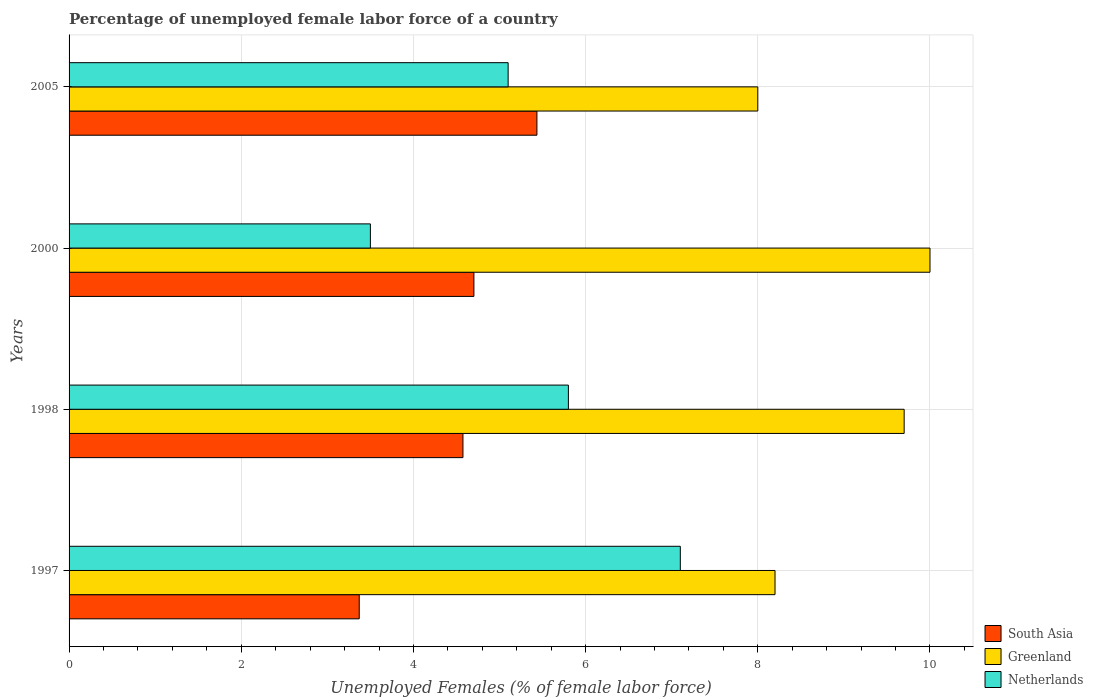How many groups of bars are there?
Provide a succinct answer. 4. Are the number of bars per tick equal to the number of legend labels?
Offer a very short reply. Yes. Are the number of bars on each tick of the Y-axis equal?
Offer a terse response. Yes. How many bars are there on the 3rd tick from the bottom?
Your answer should be compact. 3. What is the percentage of unemployed female labor force in South Asia in 1998?
Offer a very short reply. 4.58. Across all years, what is the maximum percentage of unemployed female labor force in South Asia?
Your answer should be compact. 5.43. Across all years, what is the minimum percentage of unemployed female labor force in South Asia?
Make the answer very short. 3.37. In which year was the percentage of unemployed female labor force in Greenland maximum?
Offer a terse response. 2000. What is the total percentage of unemployed female labor force in Greenland in the graph?
Provide a succinct answer. 35.9. What is the difference between the percentage of unemployed female labor force in Netherlands in 2000 and the percentage of unemployed female labor force in Greenland in 1998?
Provide a short and direct response. -6.2. What is the average percentage of unemployed female labor force in Greenland per year?
Offer a terse response. 8.97. In the year 1997, what is the difference between the percentage of unemployed female labor force in Greenland and percentage of unemployed female labor force in Netherlands?
Your answer should be very brief. 1.1. In how many years, is the percentage of unemployed female labor force in Greenland greater than 6.8 %?
Offer a very short reply. 4. What is the ratio of the percentage of unemployed female labor force in Netherlands in 1998 to that in 2005?
Your response must be concise. 1.14. Is the percentage of unemployed female labor force in Greenland in 1997 less than that in 2000?
Give a very brief answer. Yes. Is the difference between the percentage of unemployed female labor force in Greenland in 1998 and 2005 greater than the difference between the percentage of unemployed female labor force in Netherlands in 1998 and 2005?
Provide a succinct answer. Yes. What is the difference between the highest and the second highest percentage of unemployed female labor force in Greenland?
Your answer should be very brief. 0.3. What is the difference between the highest and the lowest percentage of unemployed female labor force in Netherlands?
Give a very brief answer. 3.6. In how many years, is the percentage of unemployed female labor force in Netherlands greater than the average percentage of unemployed female labor force in Netherlands taken over all years?
Keep it short and to the point. 2. Is the sum of the percentage of unemployed female labor force in South Asia in 1997 and 2005 greater than the maximum percentage of unemployed female labor force in Greenland across all years?
Give a very brief answer. No. What does the 3rd bar from the top in 2005 represents?
Give a very brief answer. South Asia. What does the 2nd bar from the bottom in 1997 represents?
Offer a very short reply. Greenland. Is it the case that in every year, the sum of the percentage of unemployed female labor force in South Asia and percentage of unemployed female labor force in Greenland is greater than the percentage of unemployed female labor force in Netherlands?
Offer a very short reply. Yes. Are all the bars in the graph horizontal?
Your answer should be very brief. Yes. What is the difference between two consecutive major ticks on the X-axis?
Make the answer very short. 2. Does the graph contain grids?
Your response must be concise. Yes. Where does the legend appear in the graph?
Ensure brevity in your answer.  Bottom right. What is the title of the graph?
Offer a very short reply. Percentage of unemployed female labor force of a country. Does "Saudi Arabia" appear as one of the legend labels in the graph?
Give a very brief answer. No. What is the label or title of the X-axis?
Offer a very short reply. Unemployed Females (% of female labor force). What is the label or title of the Y-axis?
Offer a terse response. Years. What is the Unemployed Females (% of female labor force) in South Asia in 1997?
Your response must be concise. 3.37. What is the Unemployed Females (% of female labor force) of Greenland in 1997?
Provide a succinct answer. 8.2. What is the Unemployed Females (% of female labor force) of Netherlands in 1997?
Make the answer very short. 7.1. What is the Unemployed Females (% of female labor force) in South Asia in 1998?
Offer a terse response. 4.58. What is the Unemployed Females (% of female labor force) of Greenland in 1998?
Provide a short and direct response. 9.7. What is the Unemployed Females (% of female labor force) of Netherlands in 1998?
Offer a very short reply. 5.8. What is the Unemployed Females (% of female labor force) of South Asia in 2000?
Offer a very short reply. 4.7. What is the Unemployed Females (% of female labor force) in Greenland in 2000?
Provide a short and direct response. 10. What is the Unemployed Females (% of female labor force) in Netherlands in 2000?
Give a very brief answer. 3.5. What is the Unemployed Females (% of female labor force) in South Asia in 2005?
Offer a terse response. 5.43. What is the Unemployed Females (% of female labor force) of Greenland in 2005?
Provide a succinct answer. 8. What is the Unemployed Females (% of female labor force) in Netherlands in 2005?
Make the answer very short. 5.1. Across all years, what is the maximum Unemployed Females (% of female labor force) in South Asia?
Your answer should be very brief. 5.43. Across all years, what is the maximum Unemployed Females (% of female labor force) in Netherlands?
Your response must be concise. 7.1. Across all years, what is the minimum Unemployed Females (% of female labor force) in South Asia?
Give a very brief answer. 3.37. Across all years, what is the minimum Unemployed Females (% of female labor force) of Netherlands?
Make the answer very short. 3.5. What is the total Unemployed Females (% of female labor force) of South Asia in the graph?
Provide a succinct answer. 18.08. What is the total Unemployed Females (% of female labor force) in Greenland in the graph?
Provide a short and direct response. 35.9. What is the difference between the Unemployed Females (% of female labor force) of South Asia in 1997 and that in 1998?
Give a very brief answer. -1.2. What is the difference between the Unemployed Females (% of female labor force) of Greenland in 1997 and that in 1998?
Provide a short and direct response. -1.5. What is the difference between the Unemployed Females (% of female labor force) of Netherlands in 1997 and that in 1998?
Your response must be concise. 1.3. What is the difference between the Unemployed Females (% of female labor force) of South Asia in 1997 and that in 2000?
Your response must be concise. -1.33. What is the difference between the Unemployed Females (% of female labor force) in Netherlands in 1997 and that in 2000?
Provide a succinct answer. 3.6. What is the difference between the Unemployed Females (% of female labor force) in South Asia in 1997 and that in 2005?
Your answer should be compact. -2.06. What is the difference between the Unemployed Females (% of female labor force) of Netherlands in 1997 and that in 2005?
Your answer should be compact. 2. What is the difference between the Unemployed Females (% of female labor force) of South Asia in 1998 and that in 2000?
Provide a short and direct response. -0.13. What is the difference between the Unemployed Females (% of female labor force) of Greenland in 1998 and that in 2000?
Provide a short and direct response. -0.3. What is the difference between the Unemployed Females (% of female labor force) in South Asia in 1998 and that in 2005?
Your answer should be very brief. -0.86. What is the difference between the Unemployed Females (% of female labor force) in Greenland in 1998 and that in 2005?
Your response must be concise. 1.7. What is the difference between the Unemployed Females (% of female labor force) in South Asia in 2000 and that in 2005?
Give a very brief answer. -0.73. What is the difference between the Unemployed Females (% of female labor force) in Greenland in 2000 and that in 2005?
Give a very brief answer. 2. What is the difference between the Unemployed Females (% of female labor force) of Netherlands in 2000 and that in 2005?
Ensure brevity in your answer.  -1.6. What is the difference between the Unemployed Females (% of female labor force) in South Asia in 1997 and the Unemployed Females (% of female labor force) in Greenland in 1998?
Offer a very short reply. -6.33. What is the difference between the Unemployed Females (% of female labor force) of South Asia in 1997 and the Unemployed Females (% of female labor force) of Netherlands in 1998?
Your answer should be compact. -2.43. What is the difference between the Unemployed Females (% of female labor force) of Greenland in 1997 and the Unemployed Females (% of female labor force) of Netherlands in 1998?
Your answer should be very brief. 2.4. What is the difference between the Unemployed Females (% of female labor force) of South Asia in 1997 and the Unemployed Females (% of female labor force) of Greenland in 2000?
Make the answer very short. -6.63. What is the difference between the Unemployed Females (% of female labor force) in South Asia in 1997 and the Unemployed Females (% of female labor force) in Netherlands in 2000?
Your response must be concise. -0.13. What is the difference between the Unemployed Females (% of female labor force) of Greenland in 1997 and the Unemployed Females (% of female labor force) of Netherlands in 2000?
Give a very brief answer. 4.7. What is the difference between the Unemployed Females (% of female labor force) of South Asia in 1997 and the Unemployed Females (% of female labor force) of Greenland in 2005?
Your response must be concise. -4.63. What is the difference between the Unemployed Females (% of female labor force) of South Asia in 1997 and the Unemployed Females (% of female labor force) of Netherlands in 2005?
Your response must be concise. -1.73. What is the difference between the Unemployed Females (% of female labor force) of Greenland in 1997 and the Unemployed Females (% of female labor force) of Netherlands in 2005?
Make the answer very short. 3.1. What is the difference between the Unemployed Females (% of female labor force) in South Asia in 1998 and the Unemployed Females (% of female labor force) in Greenland in 2000?
Make the answer very short. -5.42. What is the difference between the Unemployed Females (% of female labor force) in South Asia in 1998 and the Unemployed Females (% of female labor force) in Netherlands in 2000?
Make the answer very short. 1.08. What is the difference between the Unemployed Females (% of female labor force) of Greenland in 1998 and the Unemployed Females (% of female labor force) of Netherlands in 2000?
Give a very brief answer. 6.2. What is the difference between the Unemployed Females (% of female labor force) of South Asia in 1998 and the Unemployed Females (% of female labor force) of Greenland in 2005?
Make the answer very short. -3.42. What is the difference between the Unemployed Females (% of female labor force) in South Asia in 1998 and the Unemployed Females (% of female labor force) in Netherlands in 2005?
Your answer should be compact. -0.52. What is the difference between the Unemployed Females (% of female labor force) of South Asia in 2000 and the Unemployed Females (% of female labor force) of Greenland in 2005?
Give a very brief answer. -3.3. What is the difference between the Unemployed Females (% of female labor force) in South Asia in 2000 and the Unemployed Females (% of female labor force) in Netherlands in 2005?
Ensure brevity in your answer.  -0.4. What is the average Unemployed Females (% of female labor force) of South Asia per year?
Provide a succinct answer. 4.52. What is the average Unemployed Females (% of female labor force) of Greenland per year?
Offer a very short reply. 8.97. What is the average Unemployed Females (% of female labor force) of Netherlands per year?
Give a very brief answer. 5.38. In the year 1997, what is the difference between the Unemployed Females (% of female labor force) in South Asia and Unemployed Females (% of female labor force) in Greenland?
Make the answer very short. -4.83. In the year 1997, what is the difference between the Unemployed Females (% of female labor force) in South Asia and Unemployed Females (% of female labor force) in Netherlands?
Your answer should be very brief. -3.73. In the year 1998, what is the difference between the Unemployed Females (% of female labor force) in South Asia and Unemployed Females (% of female labor force) in Greenland?
Your answer should be very brief. -5.12. In the year 1998, what is the difference between the Unemployed Females (% of female labor force) of South Asia and Unemployed Females (% of female labor force) of Netherlands?
Offer a terse response. -1.22. In the year 2000, what is the difference between the Unemployed Females (% of female labor force) of South Asia and Unemployed Females (% of female labor force) of Greenland?
Ensure brevity in your answer.  -5.3. In the year 2000, what is the difference between the Unemployed Females (% of female labor force) in South Asia and Unemployed Females (% of female labor force) in Netherlands?
Provide a short and direct response. 1.2. In the year 2000, what is the difference between the Unemployed Females (% of female labor force) of Greenland and Unemployed Females (% of female labor force) of Netherlands?
Keep it short and to the point. 6.5. In the year 2005, what is the difference between the Unemployed Females (% of female labor force) in South Asia and Unemployed Females (% of female labor force) in Greenland?
Make the answer very short. -2.57. In the year 2005, what is the difference between the Unemployed Females (% of female labor force) in South Asia and Unemployed Females (% of female labor force) in Netherlands?
Your answer should be compact. 0.33. What is the ratio of the Unemployed Females (% of female labor force) in South Asia in 1997 to that in 1998?
Provide a short and direct response. 0.74. What is the ratio of the Unemployed Females (% of female labor force) of Greenland in 1997 to that in 1998?
Make the answer very short. 0.85. What is the ratio of the Unemployed Females (% of female labor force) of Netherlands in 1997 to that in 1998?
Make the answer very short. 1.22. What is the ratio of the Unemployed Females (% of female labor force) in South Asia in 1997 to that in 2000?
Provide a succinct answer. 0.72. What is the ratio of the Unemployed Females (% of female labor force) in Greenland in 1997 to that in 2000?
Your answer should be compact. 0.82. What is the ratio of the Unemployed Females (% of female labor force) in Netherlands in 1997 to that in 2000?
Give a very brief answer. 2.03. What is the ratio of the Unemployed Females (% of female labor force) in South Asia in 1997 to that in 2005?
Provide a short and direct response. 0.62. What is the ratio of the Unemployed Females (% of female labor force) in Greenland in 1997 to that in 2005?
Keep it short and to the point. 1.02. What is the ratio of the Unemployed Females (% of female labor force) in Netherlands in 1997 to that in 2005?
Ensure brevity in your answer.  1.39. What is the ratio of the Unemployed Females (% of female labor force) in South Asia in 1998 to that in 2000?
Give a very brief answer. 0.97. What is the ratio of the Unemployed Females (% of female labor force) in Netherlands in 1998 to that in 2000?
Give a very brief answer. 1.66. What is the ratio of the Unemployed Females (% of female labor force) of South Asia in 1998 to that in 2005?
Your response must be concise. 0.84. What is the ratio of the Unemployed Females (% of female labor force) in Greenland in 1998 to that in 2005?
Provide a succinct answer. 1.21. What is the ratio of the Unemployed Females (% of female labor force) in Netherlands in 1998 to that in 2005?
Offer a very short reply. 1.14. What is the ratio of the Unemployed Females (% of female labor force) in South Asia in 2000 to that in 2005?
Your response must be concise. 0.87. What is the ratio of the Unemployed Females (% of female labor force) of Greenland in 2000 to that in 2005?
Provide a short and direct response. 1.25. What is the ratio of the Unemployed Females (% of female labor force) of Netherlands in 2000 to that in 2005?
Provide a succinct answer. 0.69. What is the difference between the highest and the second highest Unemployed Females (% of female labor force) in South Asia?
Give a very brief answer. 0.73. What is the difference between the highest and the second highest Unemployed Females (% of female labor force) of Greenland?
Provide a succinct answer. 0.3. What is the difference between the highest and the second highest Unemployed Females (% of female labor force) of Netherlands?
Give a very brief answer. 1.3. What is the difference between the highest and the lowest Unemployed Females (% of female labor force) in South Asia?
Ensure brevity in your answer.  2.06. 